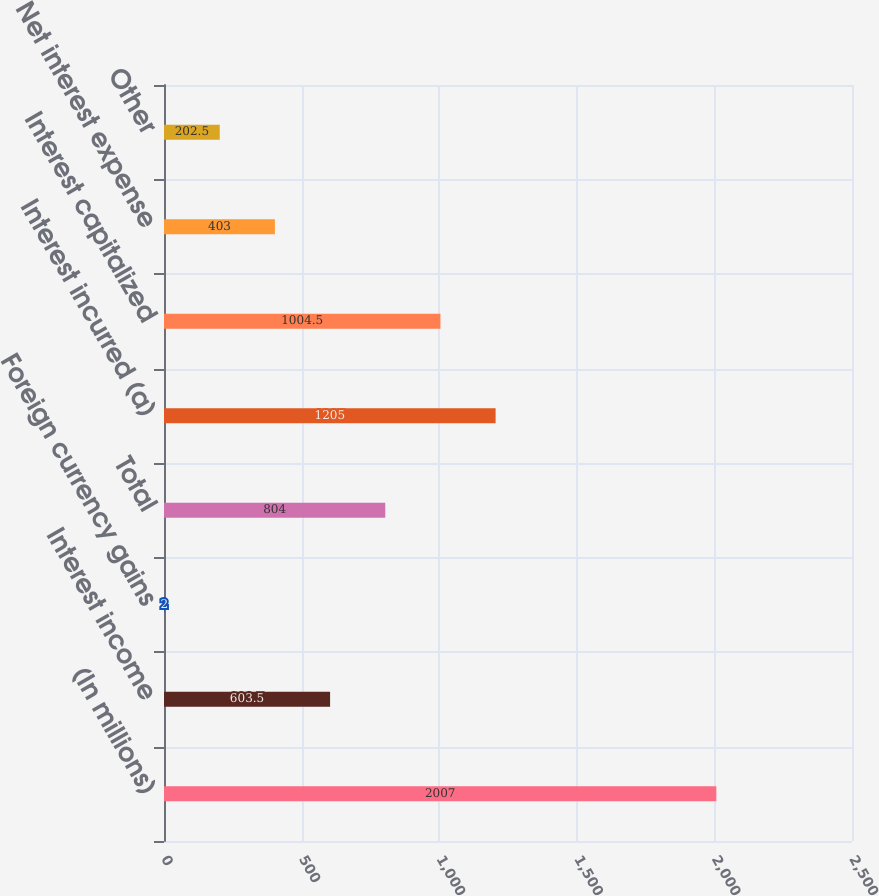Convert chart. <chart><loc_0><loc_0><loc_500><loc_500><bar_chart><fcel>(In millions)<fcel>Interest income<fcel>Foreign currency gains<fcel>Total<fcel>Interest incurred (a)<fcel>Interest capitalized<fcel>Net interest expense<fcel>Other<nl><fcel>2007<fcel>603.5<fcel>2<fcel>804<fcel>1205<fcel>1004.5<fcel>403<fcel>202.5<nl></chart> 